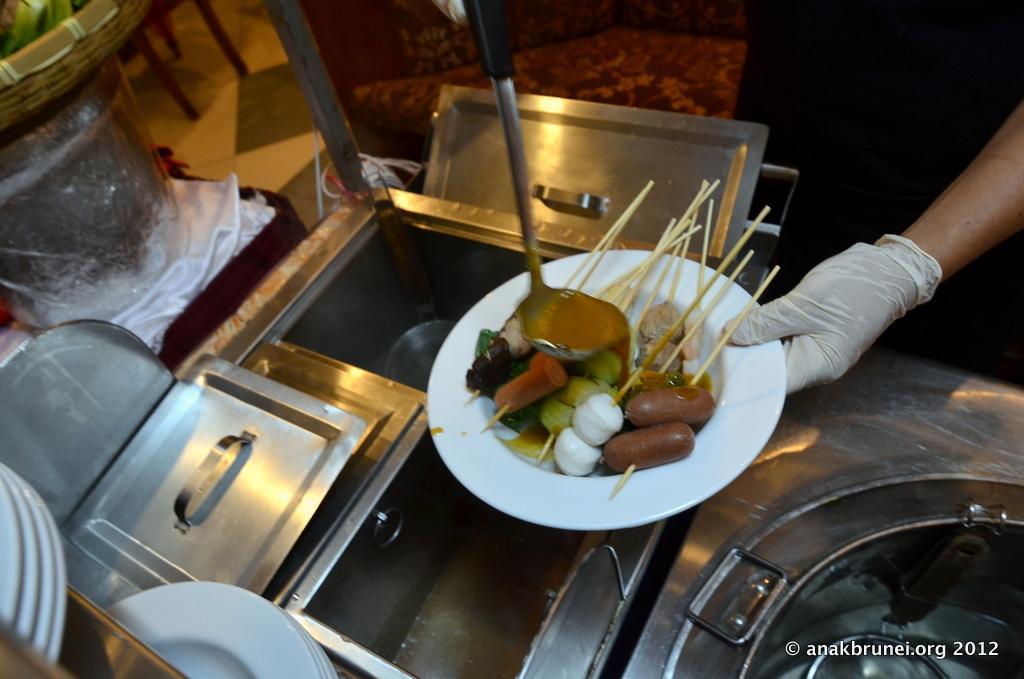Please provide a concise description of this image. In this picture we can see a person's hand, who is a holding white plate. On that plate we can hot dog, meat and other food items. On the bottom we can see wash basin, white plates and other objects. On the bottom right corner there is a watermark. On the top left we can see basket on the rack. 